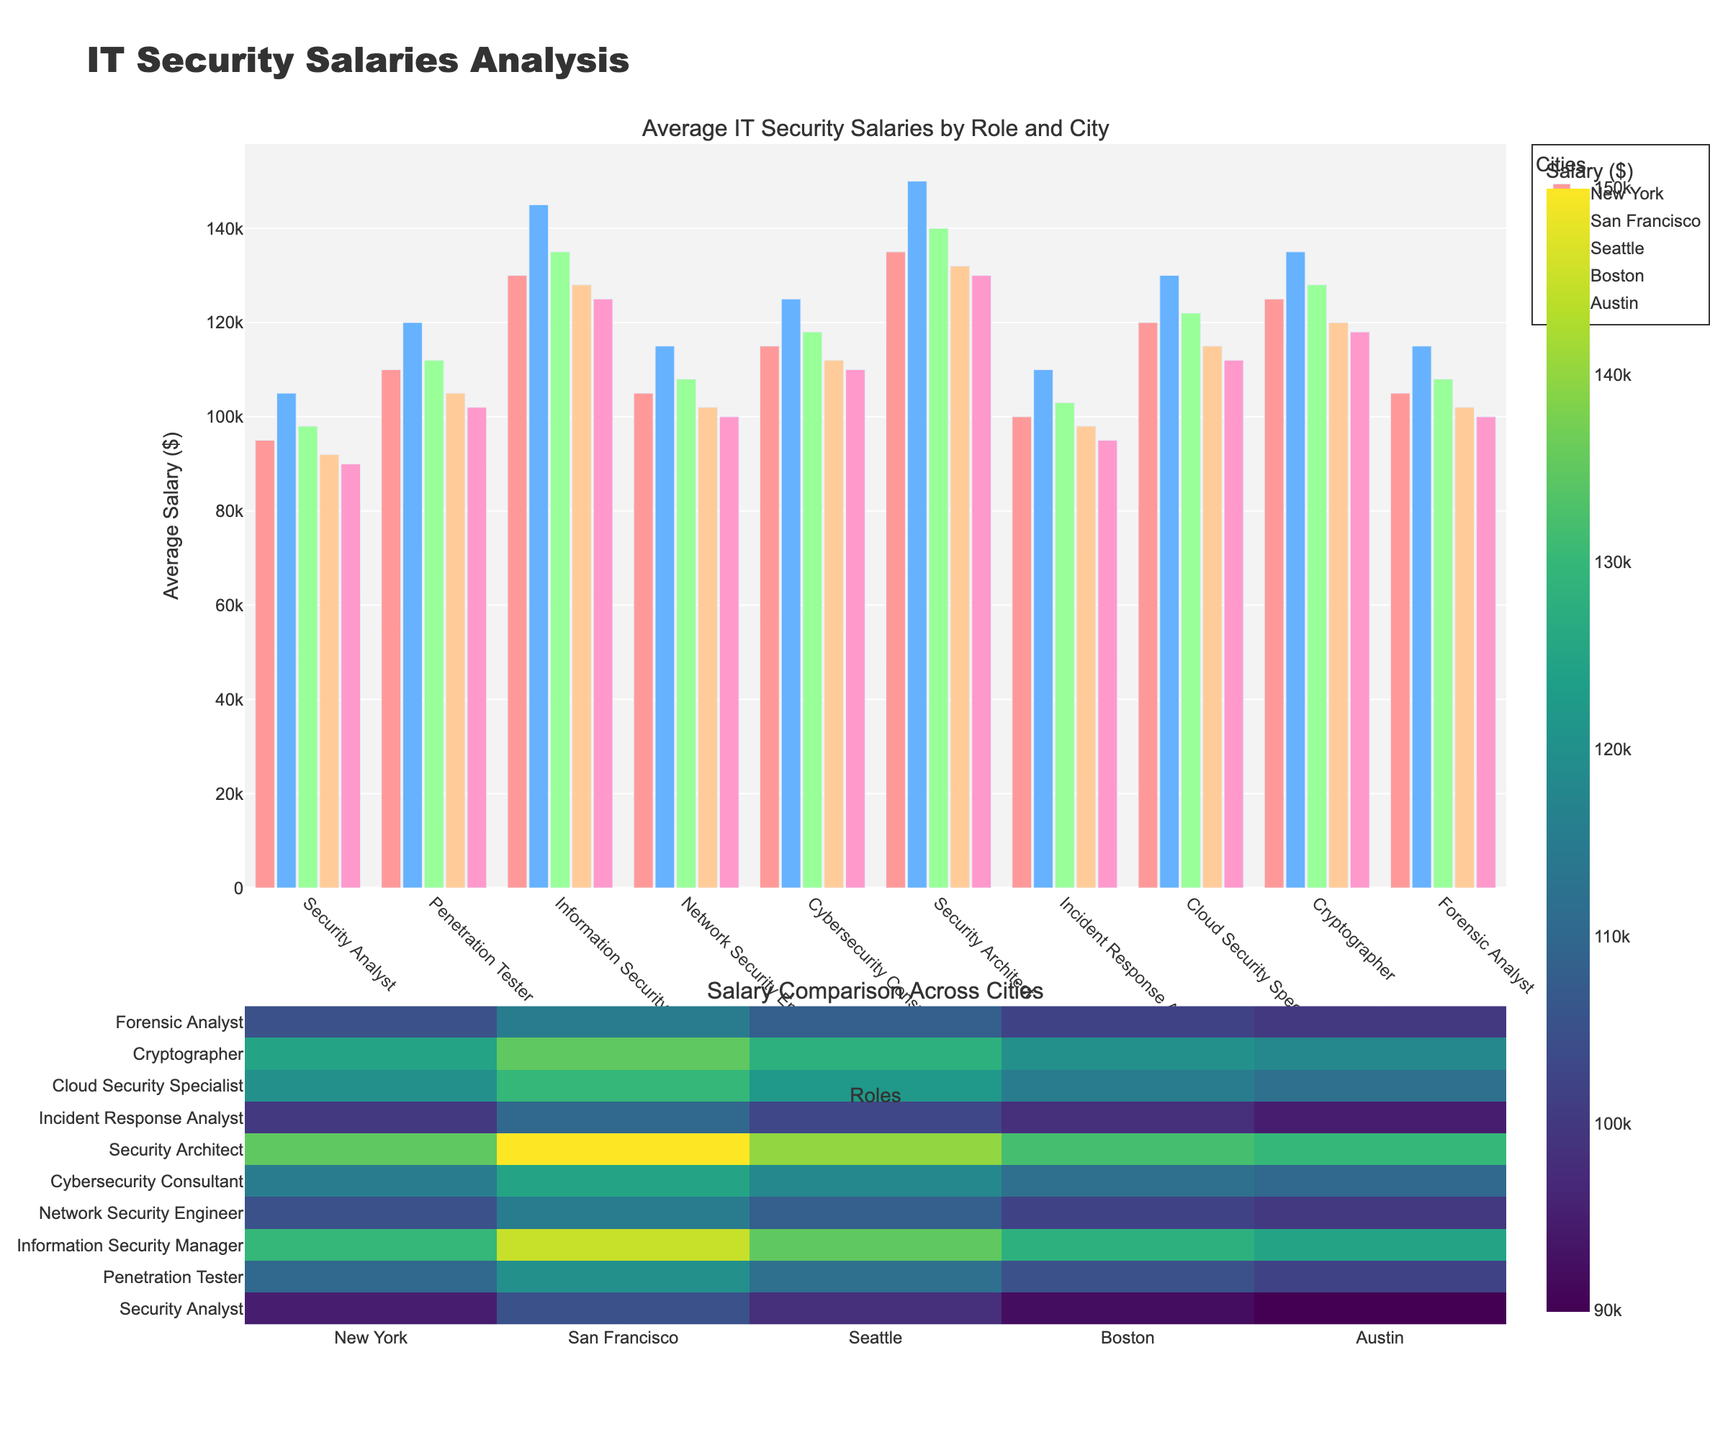What's the average salary for a Cybersecurity Consultant in San Francisco and Boston combined? To find the average, add the salaries of a Cybersecurity Consultant in San Francisco ($125,000) and Boston ($112,000), then divide by 2. This gives (125000 + 112000) / 2 = 237000 / 2 = 118500
Answer: 118500 Which role has the highest average salary in Seattle? The role with the highest average salary in Seattle is Security Architect at $140,000. Skimming through the roles under Seattle, none have a higher value.
Answer: Security Architect In which city does the Cryptographer have the lowest salary? In New York, a Cryptographer has a salary of $125,000. In San Francisco, the salary is $135,000. In Seattle, it’s $128,000. In Boston, it’s $120,000. In Austin, it’s $118,000. The lowest salary is in Austin at $118,000.
Answer: Austin What is the total salary for a Security Analyst across all cities? Add the salaries of a Security Analyst across New York ($95,000), San Francisco ($105,000), Seattle ($98,000), Boston ($92,000), and Austin ($90,000). The total is 95000 + 105000 + 98000 + 92000 + 90000 = 480000
Answer: 480000 Between a Network Security Engineer and a Forensic Analyst, which role has a higher average salary in Austin? A Network Security Engineer has an average salary of $100,000 in Austin, whereas a Forensic Analyst has an average salary of $100,000 in Austin. Therefore, both have the same salary.
Answer: Same What's the salary difference between a Penetration Tester and an Information Security Manager in San Francisco? The salary of a Penetration Tester in San Francisco is $120,000, while an Information Security Manager earns $145,000. The difference is 145000 - 120000 = 25000
Answer: 25000 Is there any role that has the same average salary in two different cities? Yes, a Forensic Analyst has the same average salary in Austin and Seattle at $100,000
Answer: Yes 